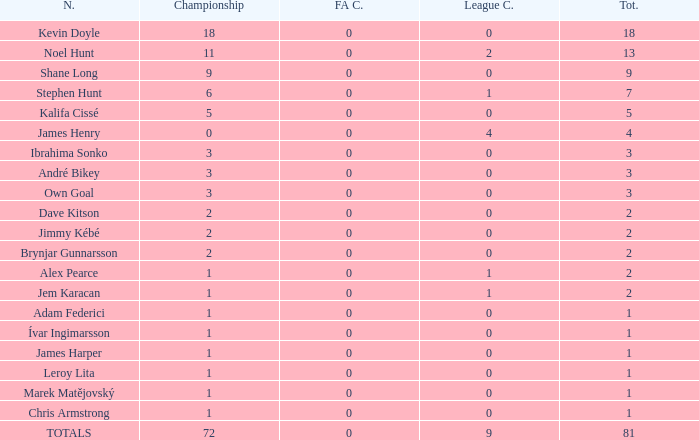What is the total championships that the league cup is less than 0? None. 